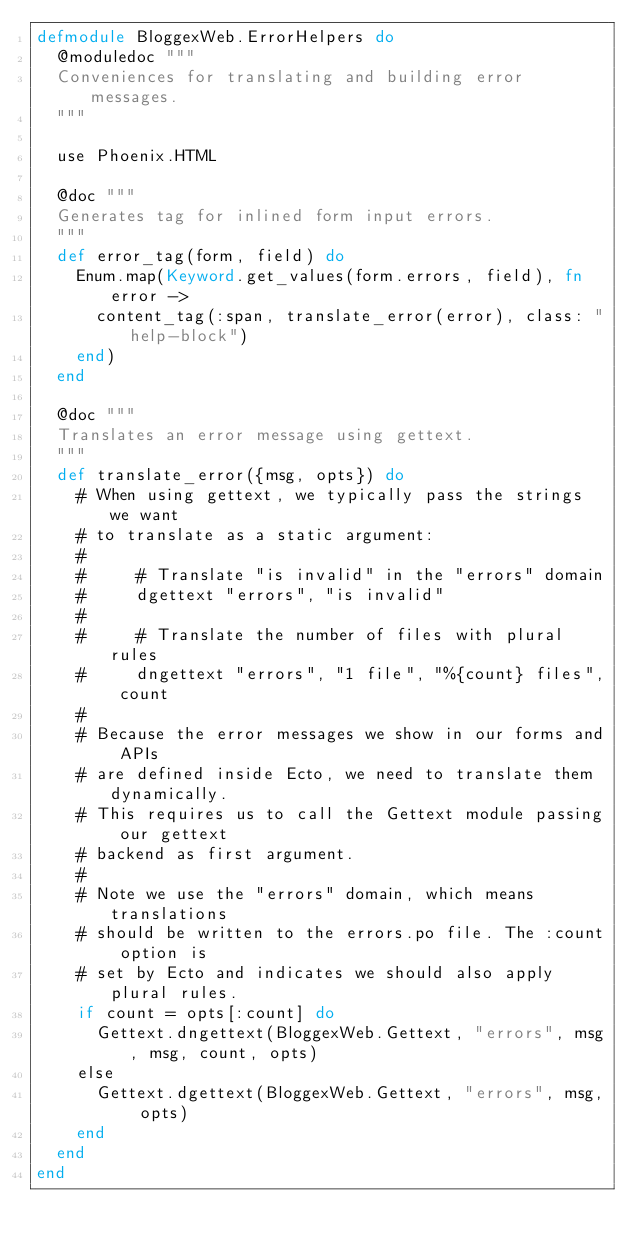Convert code to text. <code><loc_0><loc_0><loc_500><loc_500><_Elixir_>defmodule BloggexWeb.ErrorHelpers do
  @moduledoc """
  Conveniences for translating and building error messages.
  """

  use Phoenix.HTML

  @doc """
  Generates tag for inlined form input errors.
  """
  def error_tag(form, field) do
    Enum.map(Keyword.get_values(form.errors, field), fn error ->
      content_tag(:span, translate_error(error), class: "help-block")
    end)
  end

  @doc """
  Translates an error message using gettext.
  """
  def translate_error({msg, opts}) do
    # When using gettext, we typically pass the strings we want
    # to translate as a static argument:
    #
    #     # Translate "is invalid" in the "errors" domain
    #     dgettext "errors", "is invalid"
    #
    #     # Translate the number of files with plural rules
    #     dngettext "errors", "1 file", "%{count} files", count
    #
    # Because the error messages we show in our forms and APIs
    # are defined inside Ecto, we need to translate them dynamically.
    # This requires us to call the Gettext module passing our gettext
    # backend as first argument.
    #
    # Note we use the "errors" domain, which means translations
    # should be written to the errors.po file. The :count option is
    # set by Ecto and indicates we should also apply plural rules.
    if count = opts[:count] do
      Gettext.dngettext(BloggexWeb.Gettext, "errors", msg, msg, count, opts)
    else
      Gettext.dgettext(BloggexWeb.Gettext, "errors", msg, opts)
    end
  end
end
</code> 